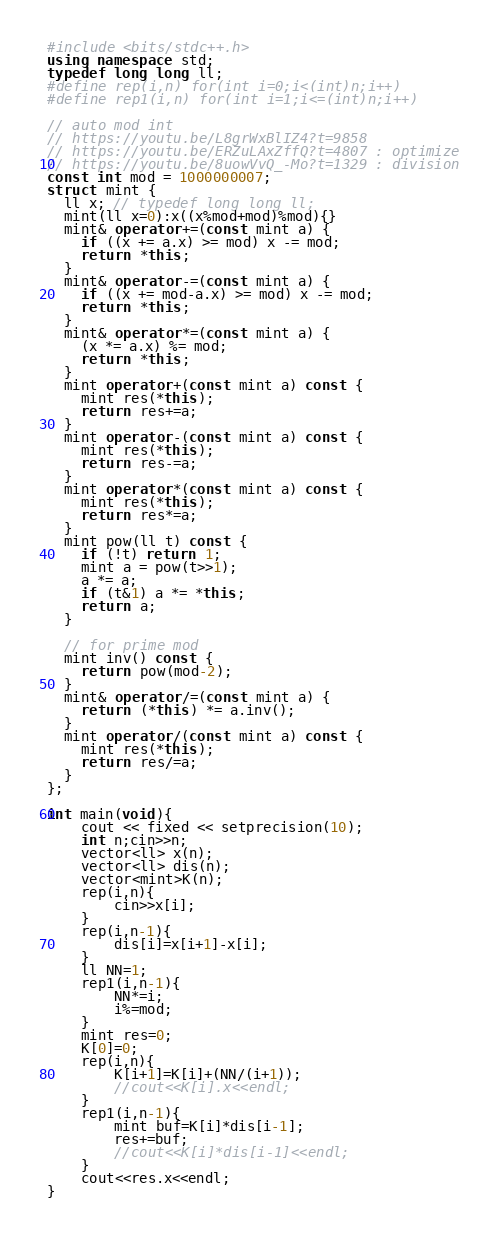<code> <loc_0><loc_0><loc_500><loc_500><_C++_>#include <bits/stdc++.h>
using namespace std;
typedef long long ll;
#define rep(i,n) for(int i=0;i<(int)n;i++)
#define rep1(i,n) for(int i=1;i<=(int)n;i++)

// auto mod int
// https://youtu.be/L8grWxBlIZ4?t=9858
// https://youtu.be/ERZuLAxZffQ?t=4807 : optimize
// https://youtu.be/8uowVvQ_-Mo?t=1329 : division
const int mod = 1000000007;
struct mint {
  ll x; // typedef long long ll;
  mint(ll x=0):x((x%mod+mod)%mod){}
  mint& operator+=(const mint a) {
    if ((x += a.x) >= mod) x -= mod;
    return *this;
  }
  mint& operator-=(const mint a) {
    if ((x += mod-a.x) >= mod) x -= mod;
    return *this;
  }
  mint& operator*=(const mint a) {
    (x *= a.x) %= mod;
    return *this;
  }
  mint operator+(const mint a) const {
    mint res(*this);
    return res+=a;
  }
  mint operator-(const mint a) const {
    mint res(*this);
    return res-=a;
  }
  mint operator*(const mint a) const {
    mint res(*this);
    return res*=a;
  }
  mint pow(ll t) const {
    if (!t) return 1;
    mint a = pow(t>>1);
    a *= a;
    if (t&1) a *= *this;
    return a;
  }

  // for prime mod
  mint inv() const {
    return pow(mod-2);
  }
  mint& operator/=(const mint a) {
    return (*this) *= a.inv();
  }
  mint operator/(const mint a) const {
    mint res(*this);
    return res/=a;
  }
};

int main(void){
    cout << fixed << setprecision(10);
    int n;cin>>n;
    vector<ll> x(n);
    vector<ll> dis(n);
    vector<mint>K(n);
    rep(i,n){
        cin>>x[i];
    }
    rep(i,n-1){
        dis[i]=x[i+1]-x[i];
    }
    ll NN=1;
    rep1(i,n-1){
        NN*=i;
        i%=mod;
    }
    mint res=0;
    K[0]=0;
    rep(i,n){
        K[i+1]=K[i]+(NN/(i+1));
        //cout<<K[i].x<<endl;
    }
    rep1(i,n-1){
        mint buf=K[i]*dis[i-1];
        res+=buf;
        //cout<<K[i]*dis[i-1]<<endl;
    }
    cout<<res.x<<endl;
}</code> 